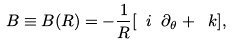Convert formula to latex. <formula><loc_0><loc_0><loc_500><loc_500>B \equiv B ( R ) = - \frac { 1 } { R } [ \ i \ \partial _ { \theta } + { \ k } ] ,</formula> 